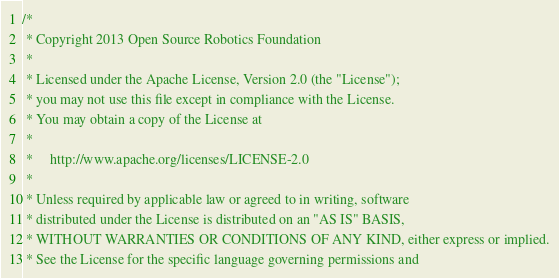Convert code to text. <code><loc_0><loc_0><loc_500><loc_500><_C++_>/*
 * Copyright 2013 Open Source Robotics Foundation
 *
 * Licensed under the Apache License, Version 2.0 (the "License");
 * you may not use this file except in compliance with the License.
 * You may obtain a copy of the License at
 *
 *     http://www.apache.org/licenses/LICENSE-2.0
 *
 * Unless required by applicable law or agreed to in writing, software
 * distributed under the License is distributed on an "AS IS" BASIS,
 * WITHOUT WARRANTIES OR CONDITIONS OF ANY KIND, either express or implied.
 * See the License for the specific language governing permissions and</code> 